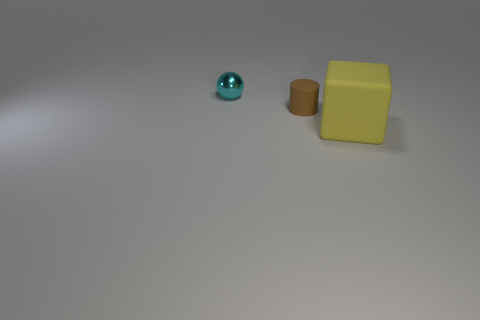Is there anything else that has the same material as the sphere?
Give a very brief answer. No. Is the material of the tiny thing in front of the metal thing the same as the small thing that is behind the brown cylinder?
Make the answer very short. No. How many objects are purple matte balls or things right of the sphere?
Offer a terse response. 2. Are there any large red matte objects of the same shape as the small metallic object?
Your answer should be very brief. No. How big is the rubber object that is on the left side of the object on the right side of the rubber object that is to the left of the big yellow rubber object?
Keep it short and to the point. Small. Are there an equal number of rubber objects that are in front of the large yellow thing and tiny shiny objects in front of the tiny brown rubber thing?
Give a very brief answer. Yes. What size is the yellow thing that is the same material as the small brown thing?
Give a very brief answer. Large. The tiny metallic sphere is what color?
Provide a short and direct response. Cyan. What material is the cylinder that is the same size as the cyan thing?
Your response must be concise. Rubber. There is a rubber object that is to the left of the big matte block; are there any small cylinders that are in front of it?
Your answer should be very brief. No. 